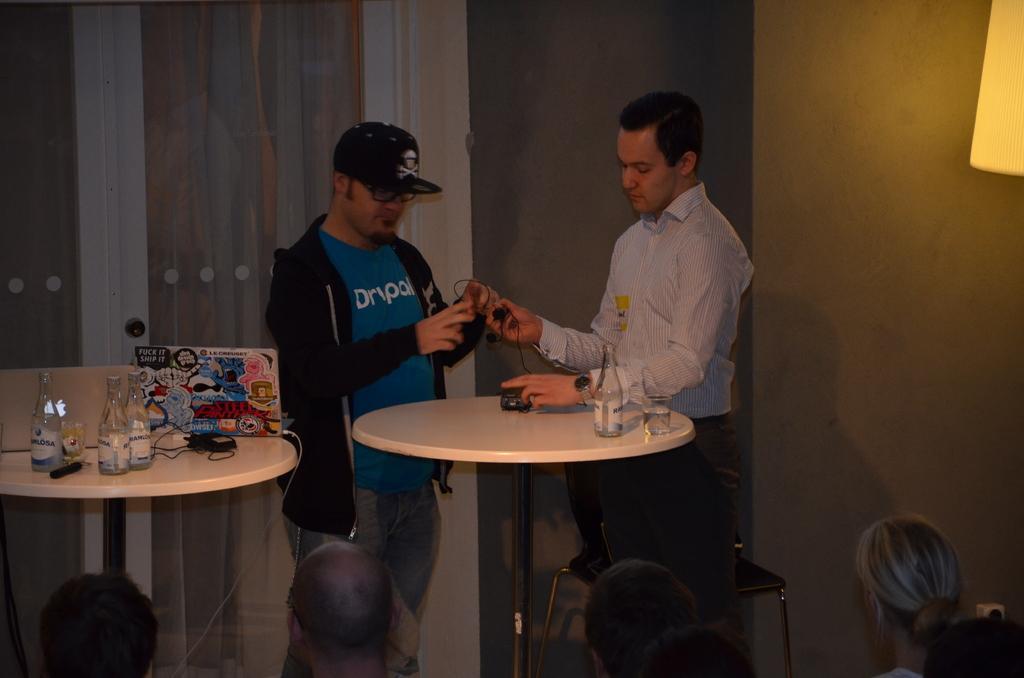Describe this image in one or two sentences. In this picture there are two persons standing at the table with a wine bottle an d a wine glass kept on table and this person is looking a the table. 